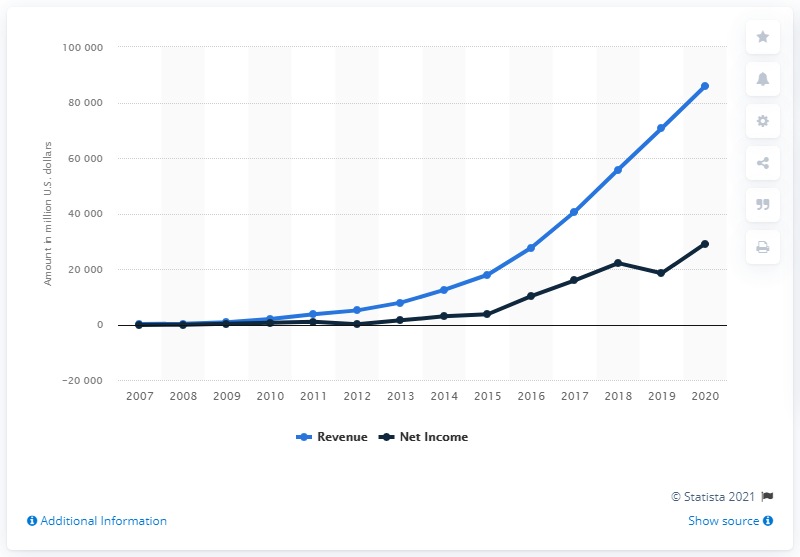List a handful of essential elements in this visual. In the year 2016, the United States held its presidential election. Facebook's net income in 2020 was $29,146 million. In 2013, Facebook's revenue was approximately 7,872. 